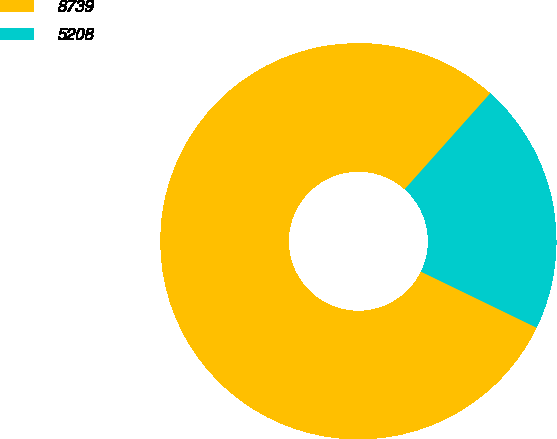Convert chart to OTSL. <chart><loc_0><loc_0><loc_500><loc_500><pie_chart><fcel>8739<fcel>5208<nl><fcel>79.41%<fcel>20.59%<nl></chart> 